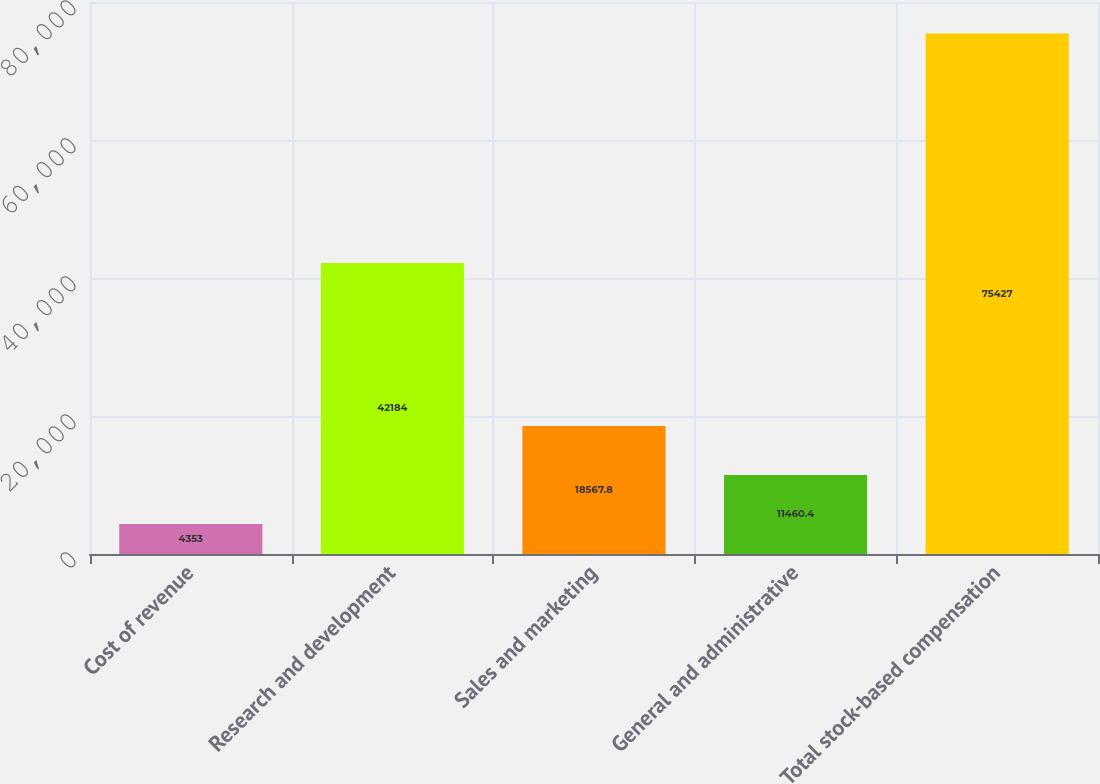<chart> <loc_0><loc_0><loc_500><loc_500><bar_chart><fcel>Cost of revenue<fcel>Research and development<fcel>Sales and marketing<fcel>General and administrative<fcel>Total stock-based compensation<nl><fcel>4353<fcel>42184<fcel>18567.8<fcel>11460.4<fcel>75427<nl></chart> 